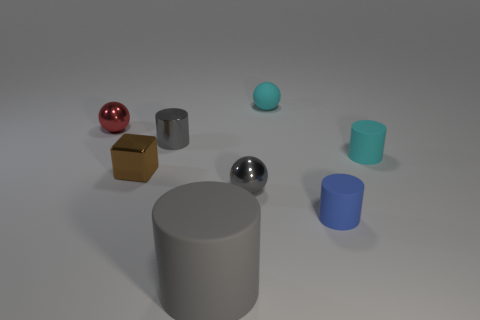Is there anything else that is the same size as the gray matte cylinder?
Your answer should be very brief. No. There is a tiny metal thing that is on the right side of the gray metal cylinder; is it the same shape as the large object?
Provide a succinct answer. No. There is a ball that is the same color as the small metallic cylinder; what is its material?
Keep it short and to the point. Metal. How many matte objects are the same color as the small rubber ball?
Make the answer very short. 1. There is a small cyan thing in front of the tiny sphere that is on the left side of the brown block; what shape is it?
Your answer should be compact. Cylinder. Is there another rubber object that has the same shape as the tiny blue rubber thing?
Provide a succinct answer. Yes. There is a big rubber object; does it have the same color as the sphere that is in front of the brown cube?
Offer a terse response. Yes. There is another cylinder that is the same color as the tiny shiny cylinder; what size is it?
Provide a succinct answer. Large. Is there a green cube that has the same size as the red metallic ball?
Make the answer very short. No. Are the blue cylinder and the small sphere in front of the red shiny thing made of the same material?
Your response must be concise. No. 